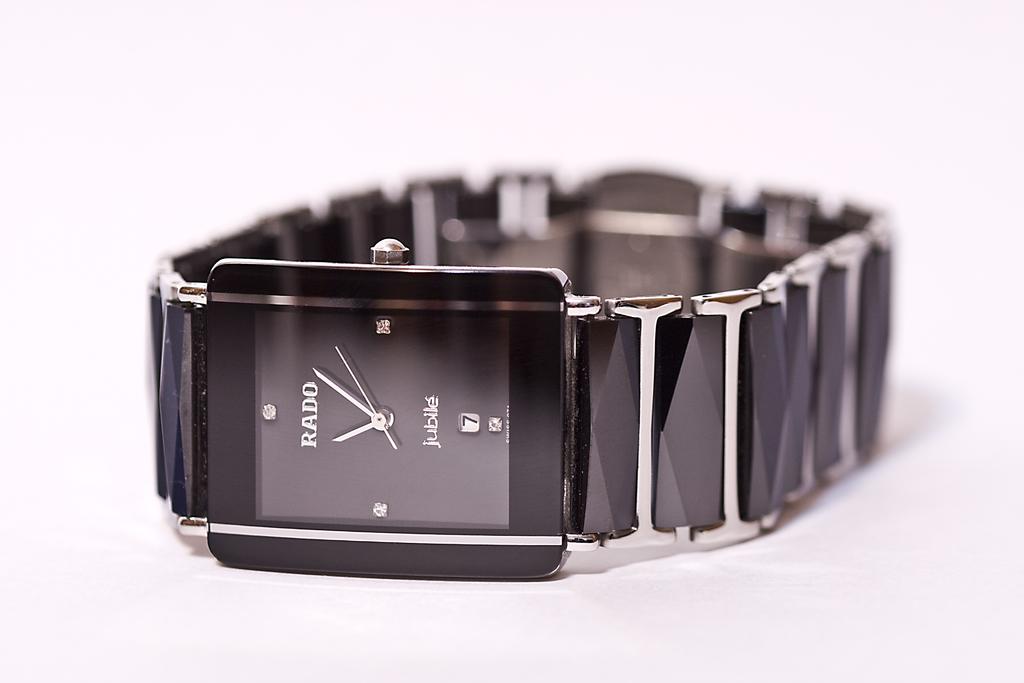What is the brand of this watch?
Provide a succinct answer. Rado. What number is in the box?
Provide a short and direct response. 7. 